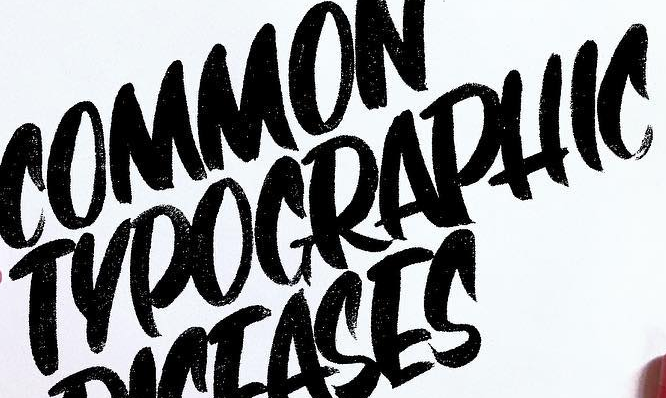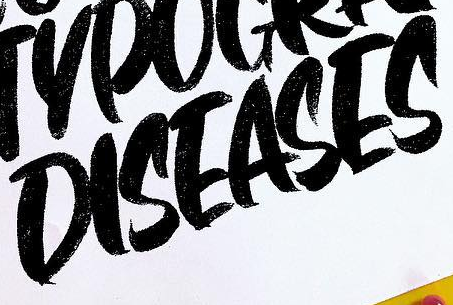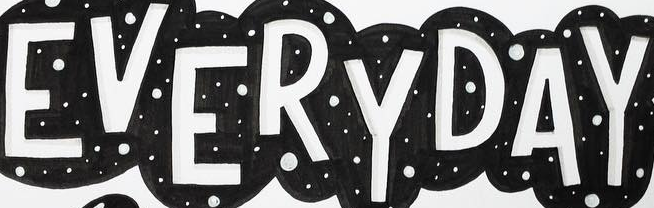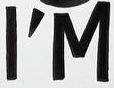What words can you see in these images in sequence, separated by a semicolon? TYPOGRAPHIC; DISEASES; EVERYDAY; I'M 